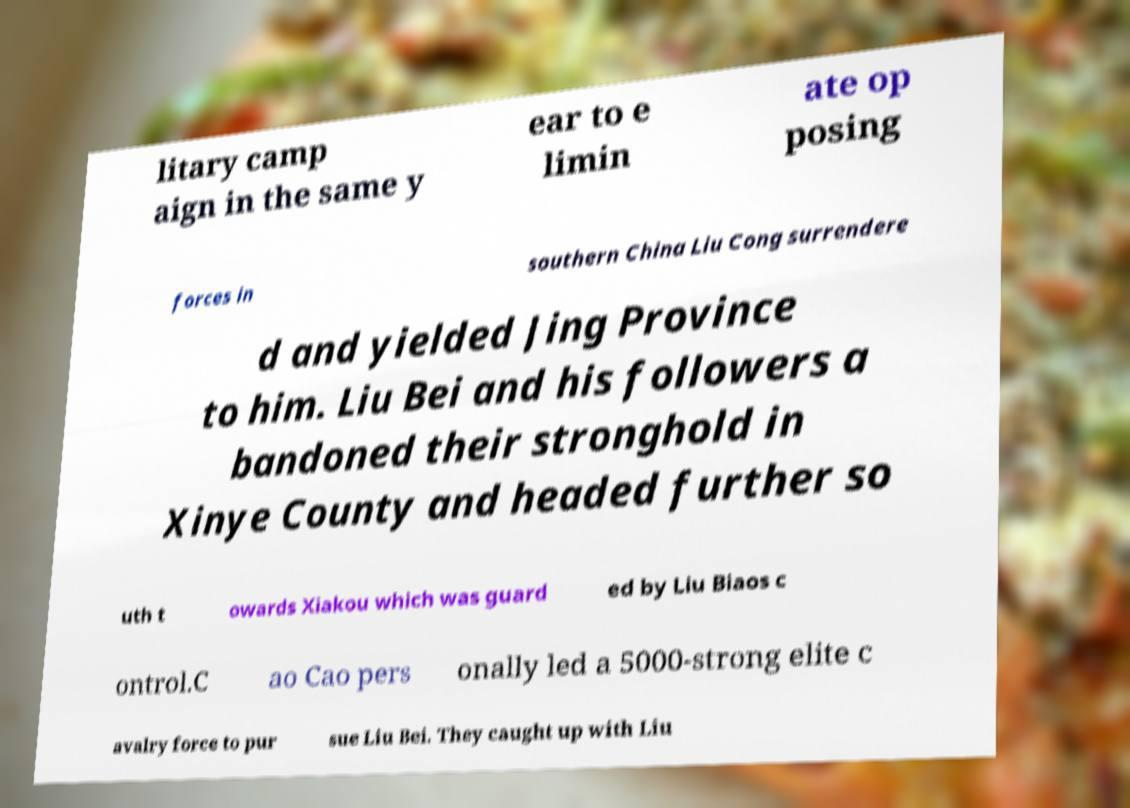Can you read and provide the text displayed in the image?This photo seems to have some interesting text. Can you extract and type it out for me? litary camp aign in the same y ear to e limin ate op posing forces in southern China Liu Cong surrendere d and yielded Jing Province to him. Liu Bei and his followers a bandoned their stronghold in Xinye County and headed further so uth t owards Xiakou which was guard ed by Liu Biaos c ontrol.C ao Cao pers onally led a 5000-strong elite c avalry force to pur sue Liu Bei. They caught up with Liu 